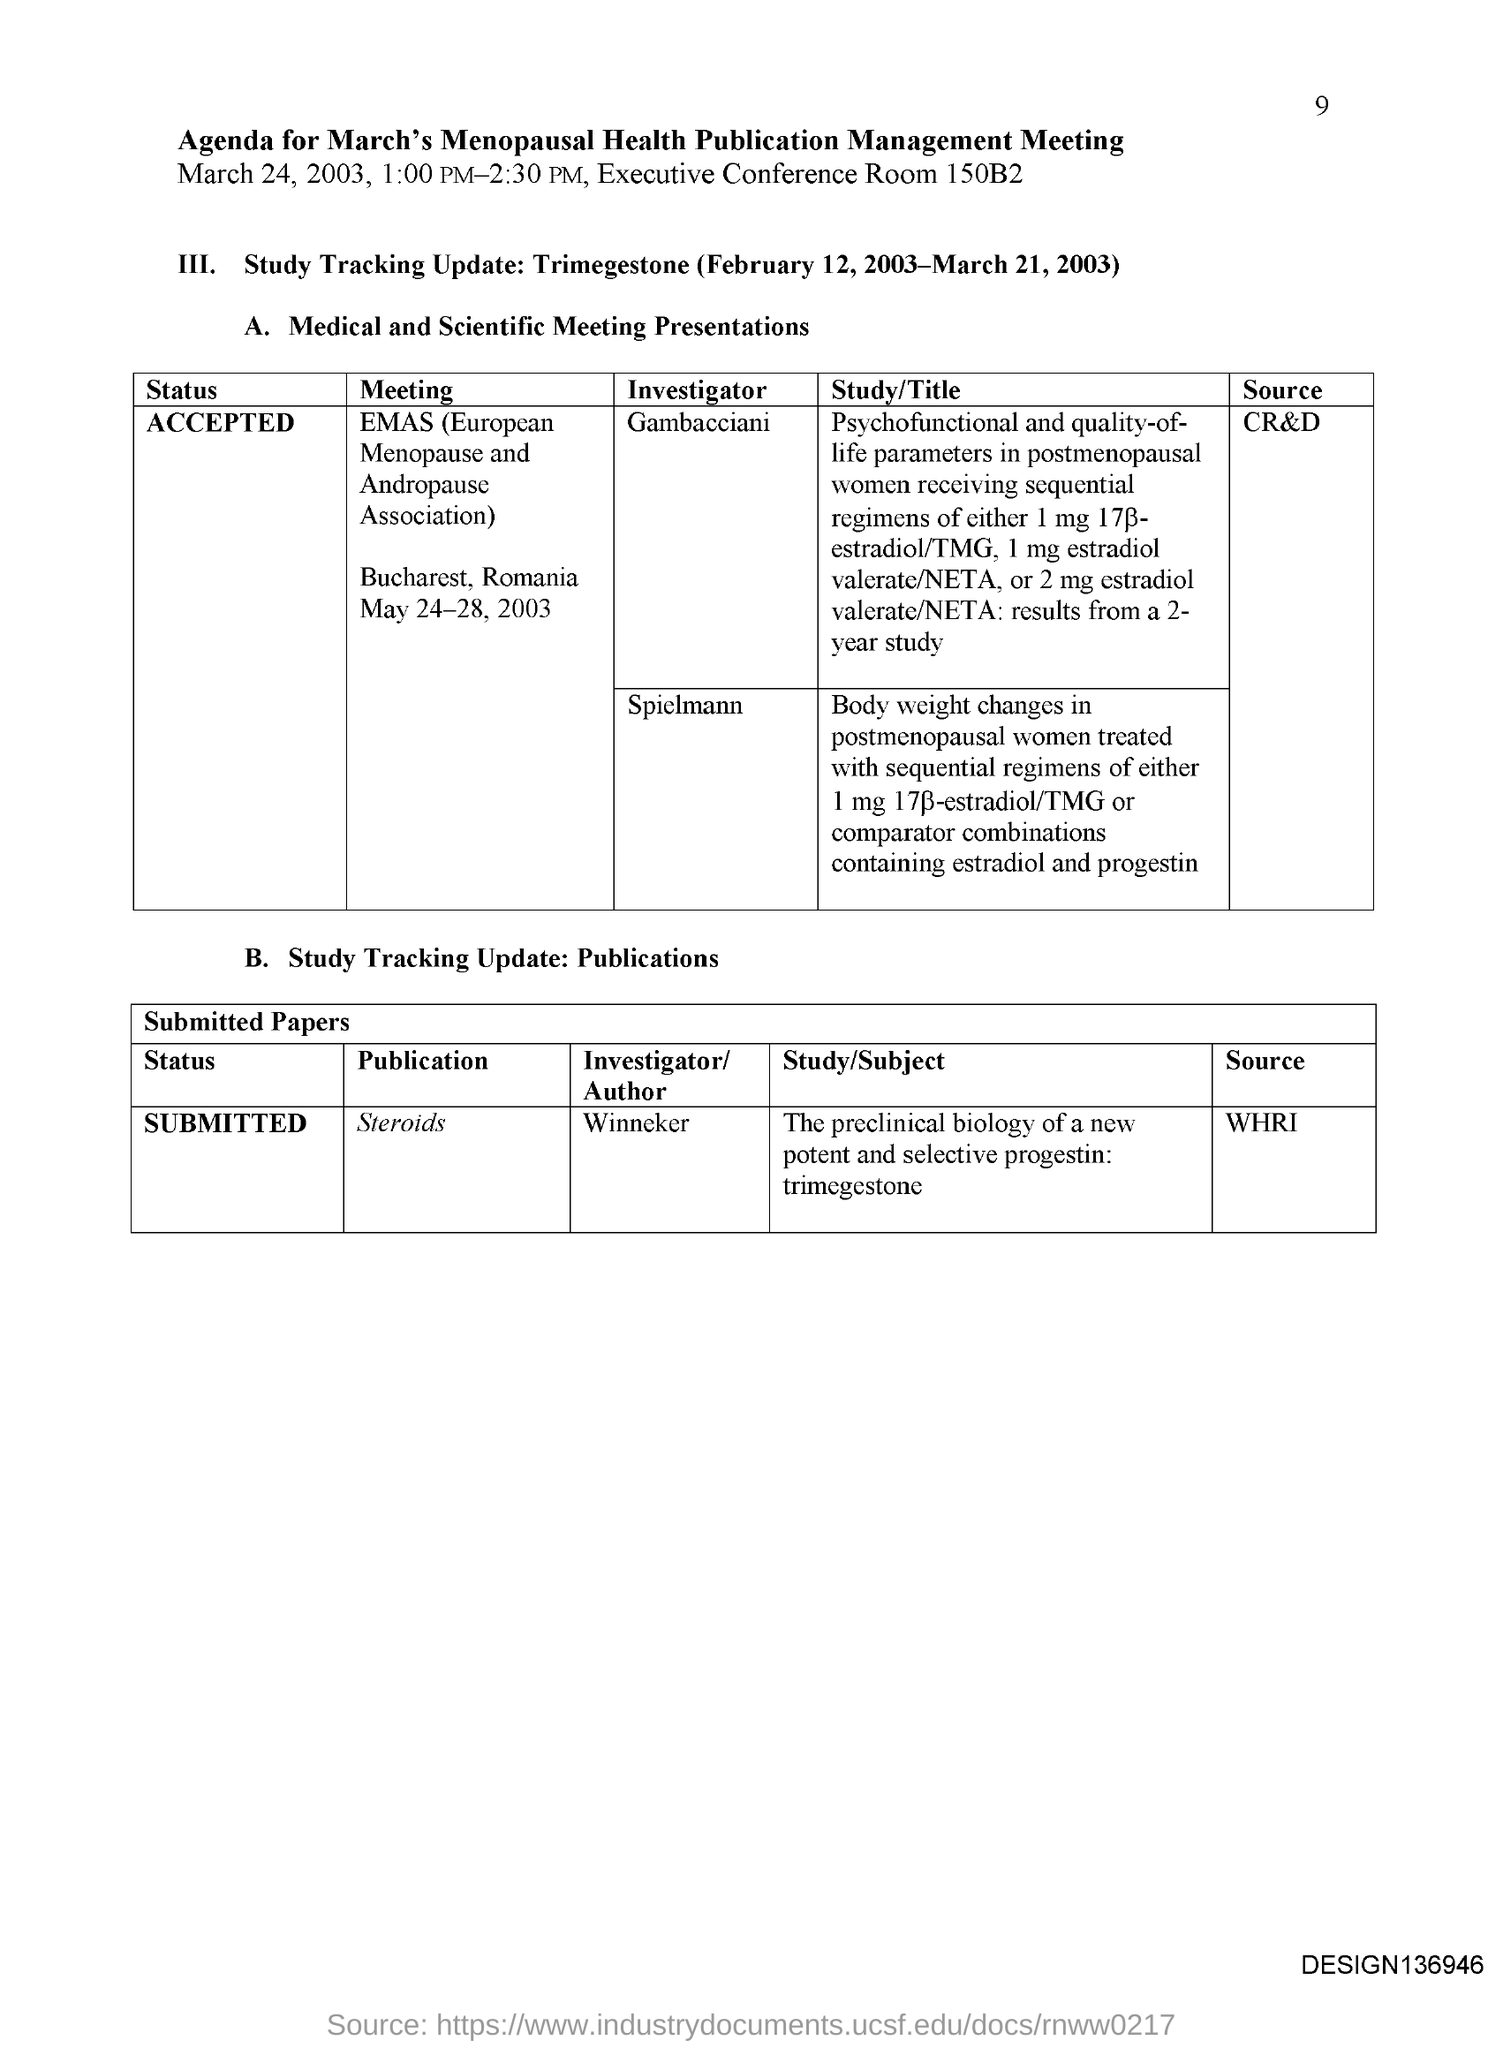Where is the EMAS meeting held?
Your answer should be compact. Bucharest, Romania. When is the EMAS meeting held?
Provide a succinct answer. May 24-28, 2003. Which meeting was Gambacciani an Investigator for?
Your answer should be compact. EMAS (European Menopause and Andropause Association). Which meeting was Spielmann an Investigator for?
Give a very brief answer. EMAS. What is the Source for Publication "steroids"?
Your answer should be very brief. WHRI. What is the Status for Publication "steroids"?
Provide a succinct answer. Submitted. What is the status for the EMAS meeting?
Your answer should be very brief. ACCEPTED. 